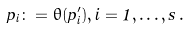Convert formula to latex. <formula><loc_0><loc_0><loc_500><loc_500>p _ { i } \colon = \theta ( p _ { i } ^ { \prime } ) , i = 1 , \dots , s \, .</formula> 